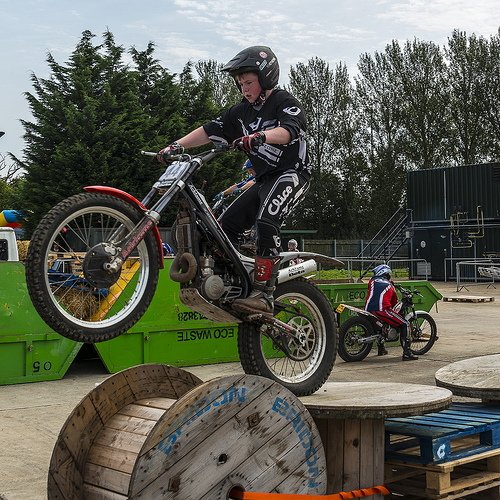<image>
Is the boy on the bike? No. The boy is not positioned on the bike. They may be near each other, but the boy is not supported by or resting on top of the bike. 